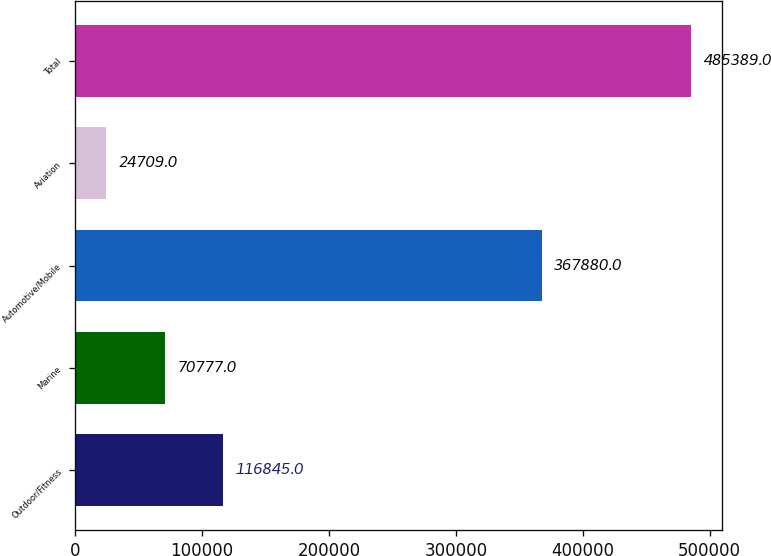<chart> <loc_0><loc_0><loc_500><loc_500><bar_chart><fcel>Outdoor/Fitness<fcel>Marine<fcel>Automotive/Mobile<fcel>Aviation<fcel>Total<nl><fcel>116845<fcel>70777<fcel>367880<fcel>24709<fcel>485389<nl></chart> 